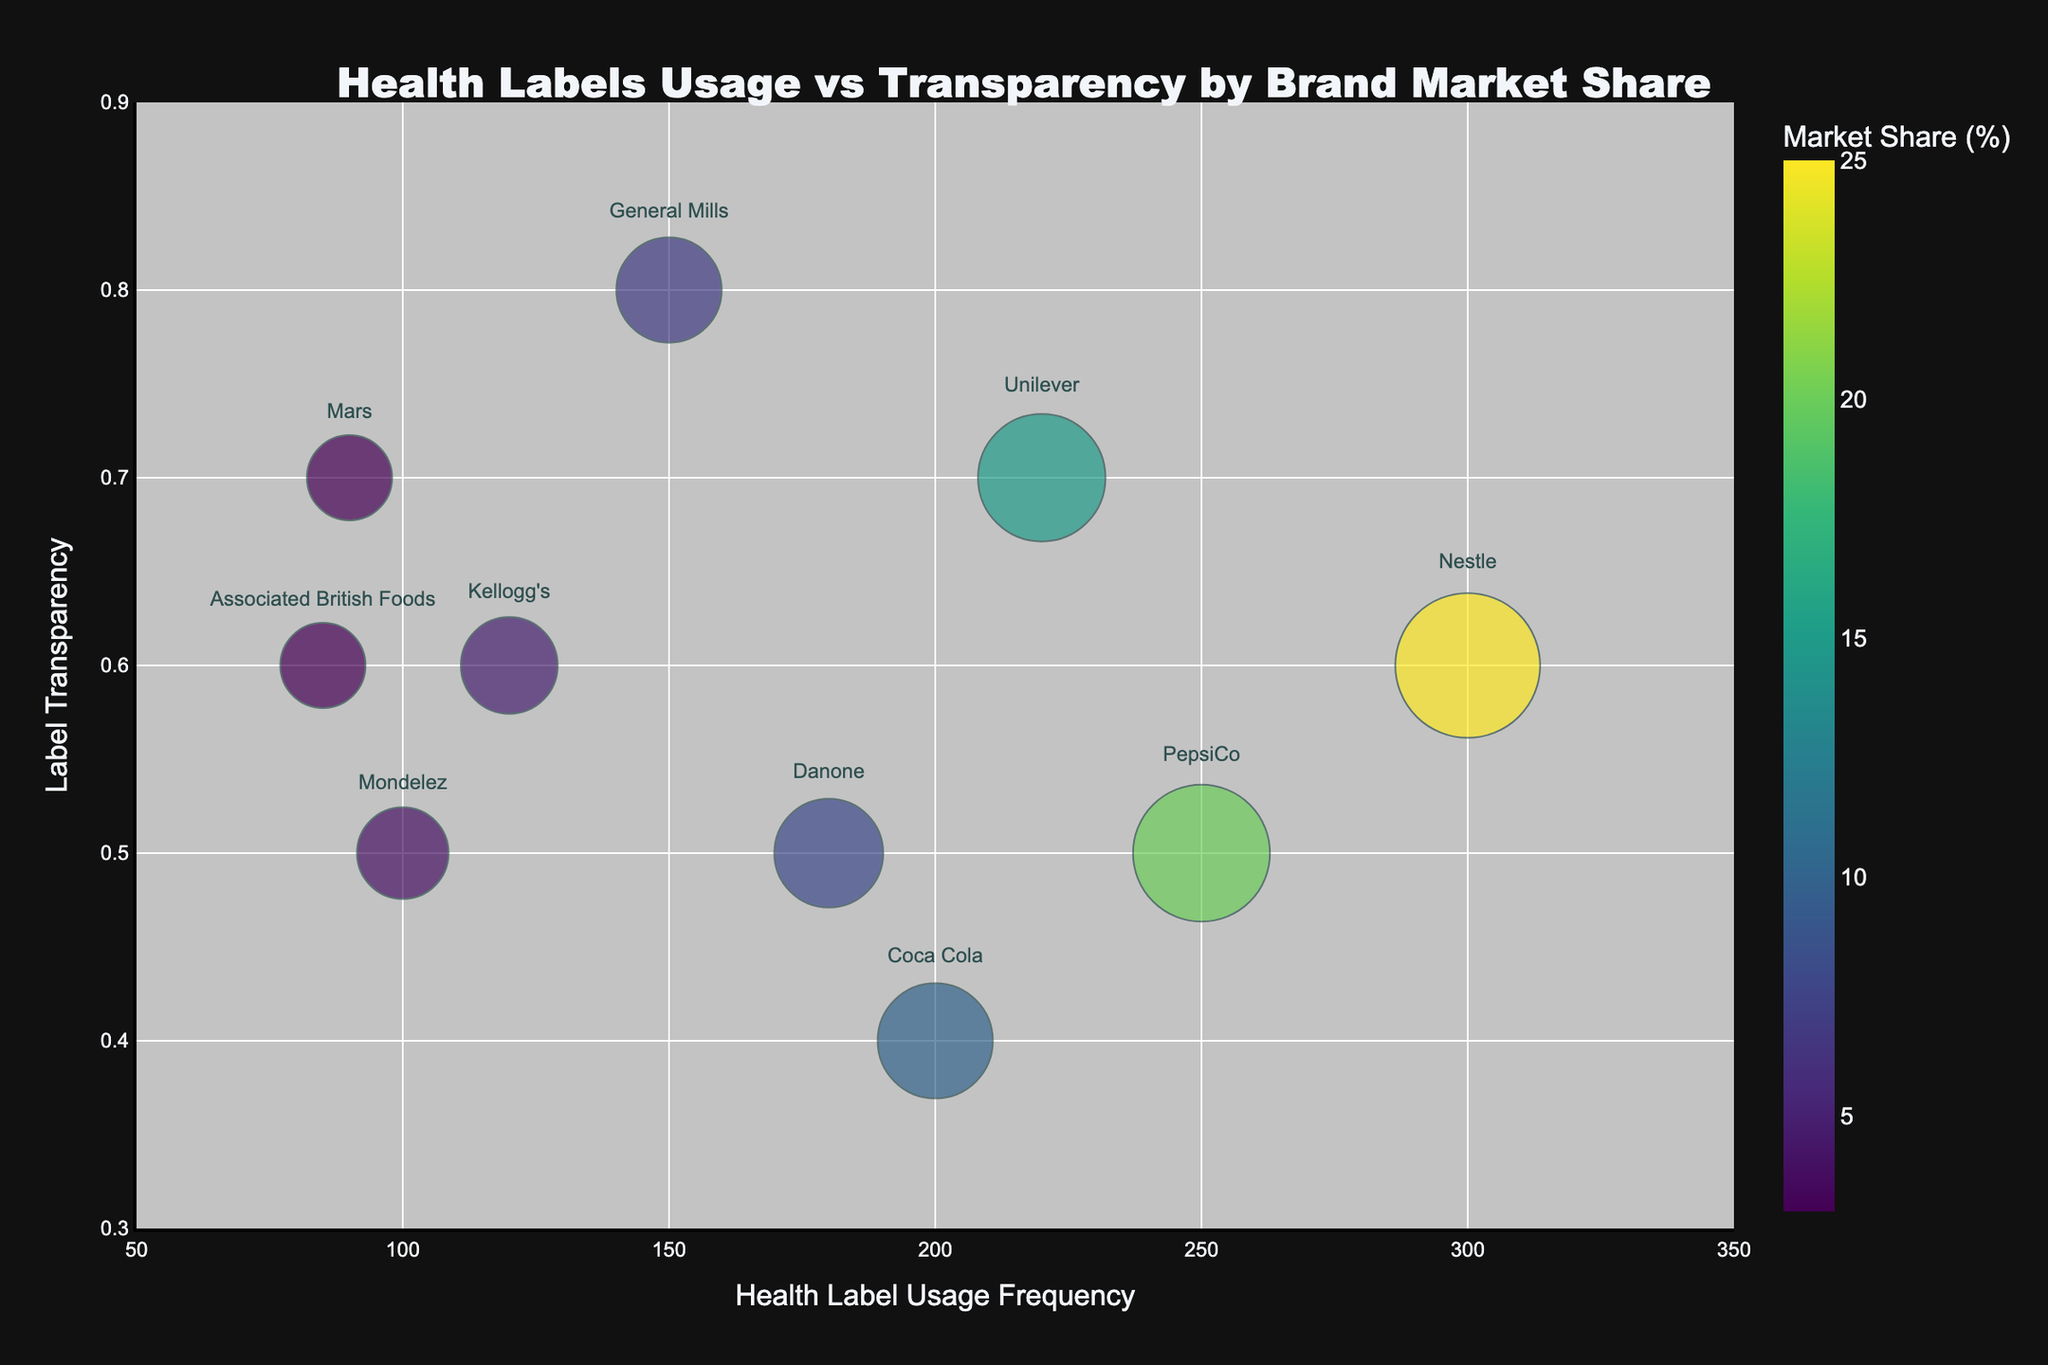What's the title of the chart? The title of the chart is located at the top center and designed to provide an overview of the data presented in the bubble chart. It summarizes the main comparison being visualized.
Answer: Health Labels Usage vs Transparency by Brand Market Share Which brand has the highest market share? By identifying the largest bubble, which corresponds to the highest market share, we can see that the brand is labeled in the chart.
Answer: Nestle How many brands have a market share less than 5%? By examining the brand labels on the bubbles in the lower market share range, we can count the number of brands that fit this criterion.
Answer: 4 Which brand shows the highest usage frequency of health labels? By locating the bubble that is positioned furthest to the right on the x-axis, corresponding to the highest health label usage frequency, we can identify the brand.
Answer: Nestle What is the average health label usage frequency for brands with a market share of 10% or higher? First, identify the brands with a market share of 10% or higher (Nestle, PepsiCo, Unilever, Coca Cola), then add their respective frequencies (300, 250, 220, 200) and divide by the number of brands (4).
Answer: 242.5 Is there any brand with both low label transparency and high health label usage frequency? By analyzing the bottom right corner of the chart where low transparency and high usage frequencies intersect, we can identify any brands in this category.
Answer: No Which brands have a label transparency above 0.6? By looking at the bubbles positioned above 0.6 on the y-axis, we can list the corresponding brands.
Answer: Unilever, General Mills, Mars Compare the market share of PepsiCo and Danone. Which one is larger? By locating the bubbles representing PepsiCo and Danone and comparing their sizes (or referring to their exact market share percentages), we can determine the larger one.
Answer: PepsiCo What's the range of health label usage frequency in the chart? Identify the minimum and maximum values of health label usage frequency on the x-axis to determine the range. The minimum value is 85 (Associated British Foods) and the maximum value is 300 (Nestle). The range is the difference between these two values.
Answer: 215 What is the market share of the brand with the lowest health label usage frequency? By finding the bubble on the far left (lowest health label usage frequency), we identify the market share noted by the size and the label.
Answer: 3% 